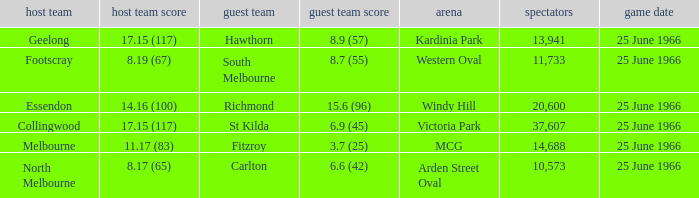When a home team scored 17.15 (117) and the away team scored 6.9 (45), what was the away team? St Kilda. 